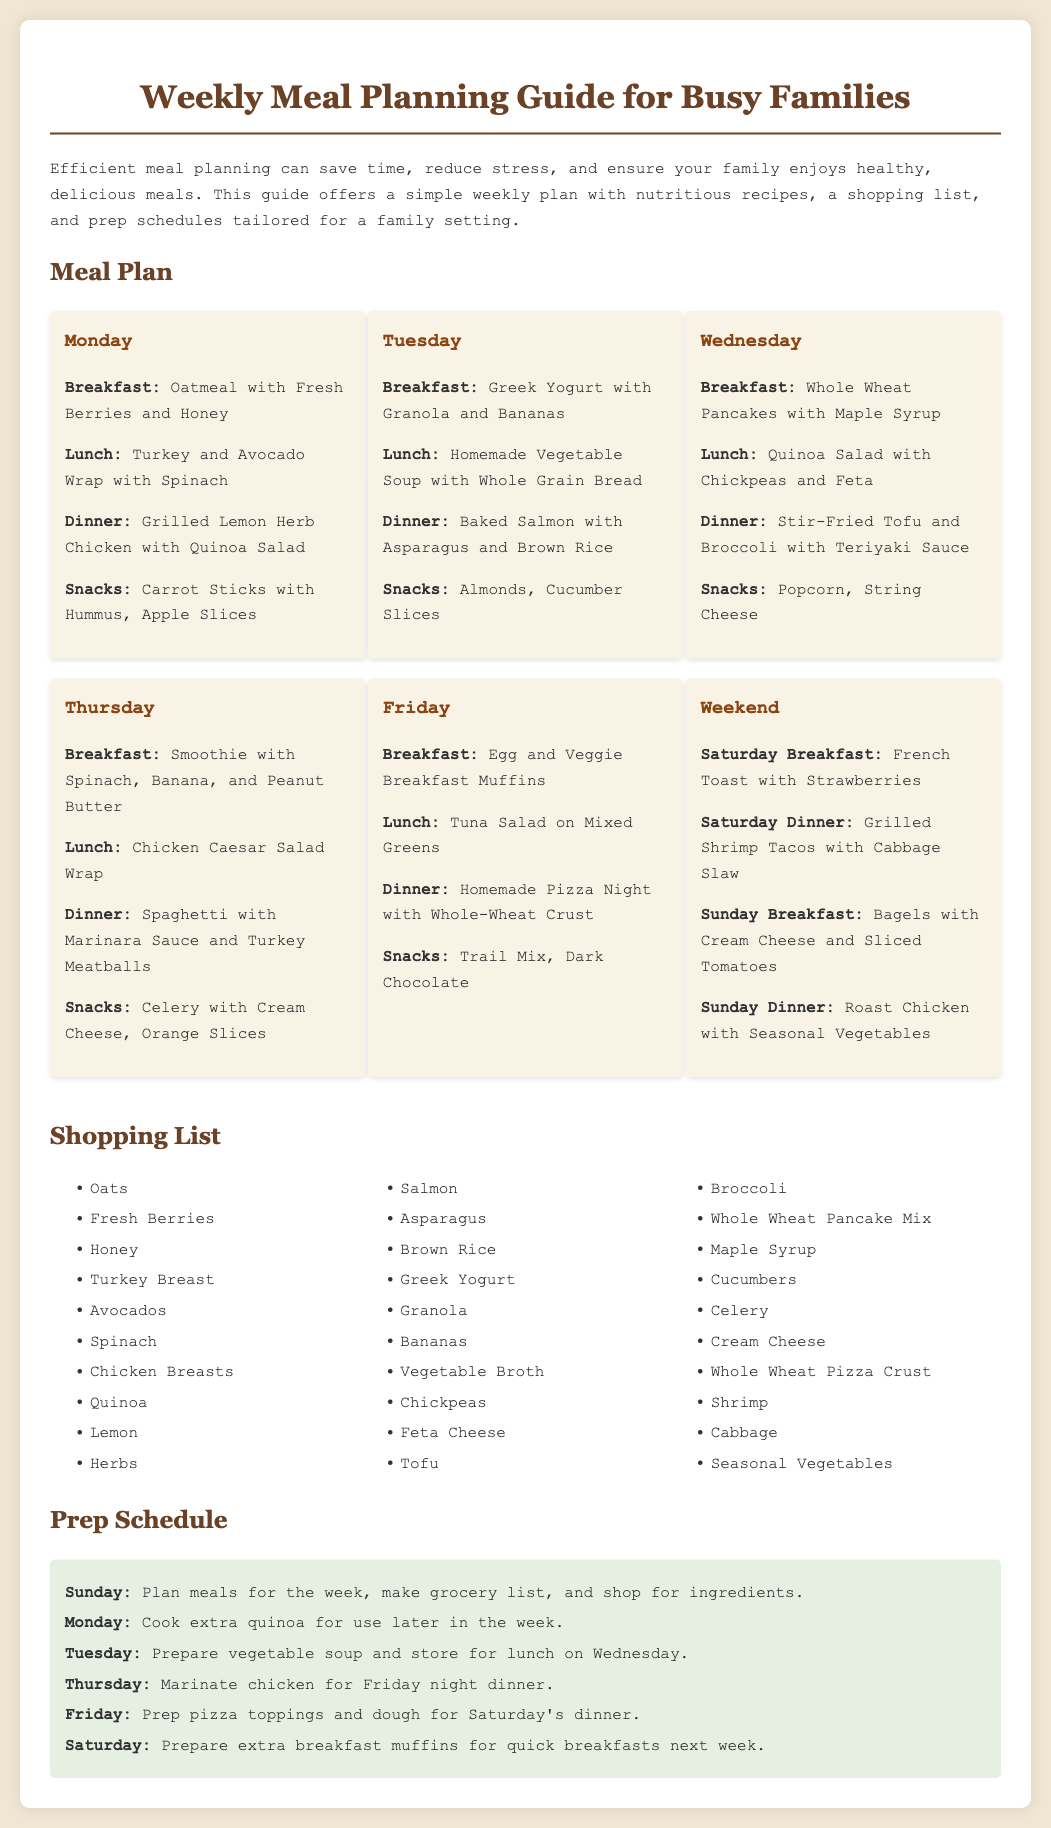What is the title of the document? The title is specified in the head section of the document and describes the content which is about meal planning.
Answer: Weekly Meal Planning Guide for Busy Families What is Tuesday's dinner? The dinner mentioned for Tuesday is listed in the meal plan section for that day and is a specific recipe.
Answer: Baked Salmon with Asparagus and Brown Rice Which day has Grilled Shrimp Tacos for dinner? This meal is outlined in the weekend section of the meal plan, under Saturday's dinner.
Answer: Saturday How many different breakfasts are listed for the week? The breakfast options are enumerated on each day of the meal plan section, allowing us to count them up.
Answer: Six What ingredient is used in the smoothie from Thursday? The ingredients for the smoothie are given in the meal plan for Thursday and specifically mention what is included.
Answer: Spinach, Banana, and Peanut Butter What should be prepared on Tuesday for Wednesday's lunch? This information is provided in the prep schedule which outlines what to do each day for efficient meal preparation.
Answer: Vegetable soup Which grain is used in the homemade pizza? The document lists the specific type of crust to be used for the pizza, which refers to a healthy option.
Answer: Whole-Wheat Crust When should extra breakfast muffins be prepared? The prep schedule clearly indicates the day set aside for this particular task.
Answer: Saturday 